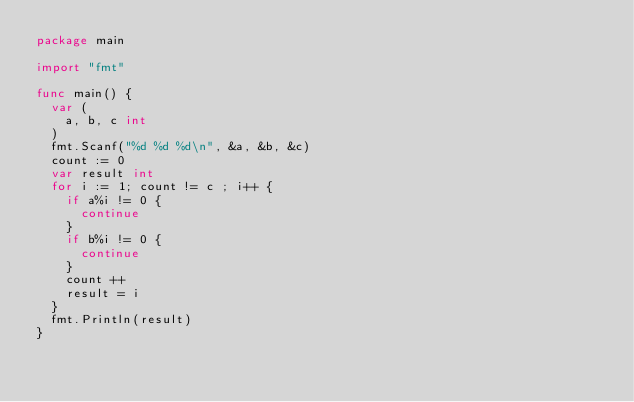<code> <loc_0><loc_0><loc_500><loc_500><_Go_>package main

import "fmt"

func main() {
	var (
		a, b, c int
	)
	fmt.Scanf("%d %d %d\n", &a, &b, &c)
	count := 0
	var result int
	for i := 1; count != c ; i++ {
		if a%i != 0 {
			continue
		}
		if b%i != 0 {
			continue
		}
		count ++
		result = i
	}
	fmt.Println(result)
}</code> 